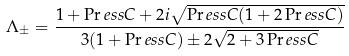<formula> <loc_0><loc_0><loc_500><loc_500>\Lambda _ { \pm } = \frac { 1 + \Pr e s s C + 2 i \sqrt { \Pr e s s C ( 1 + 2 \Pr e s s C ) } } { 3 ( 1 + \Pr e s s C ) \pm 2 \sqrt { 2 + 3 \Pr e s s C } }</formula> 